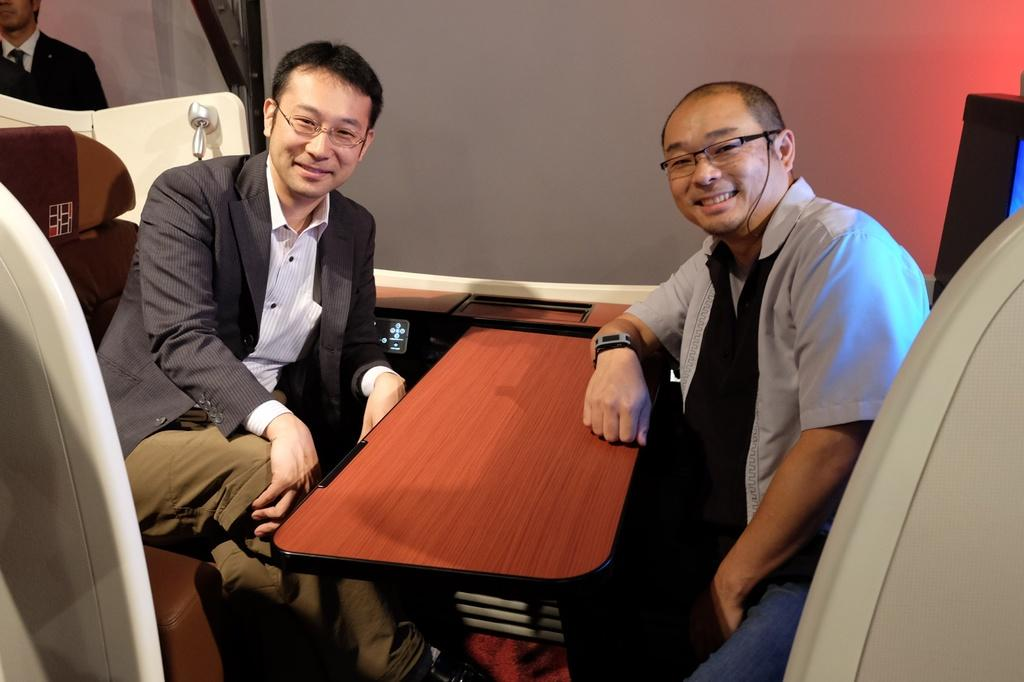How many persons are sitting in the image? There are two persons sitting on a chair in the image. What is in front of the sitting persons? There is a table in front of the sitting persons. Can you describe the person standing far from the sitting persons? The standing person is wearing a suit. What might be the purpose of the table in the image? The table might be used for placing objects or serving food. What type of oranges can be seen on the table in the image? There are no oranges present on the table in the image. What are the sitting persons talking about in the image? The conversation does not provide any information about what the sitting persons might be talking about, so it cannot be determined from the image. 